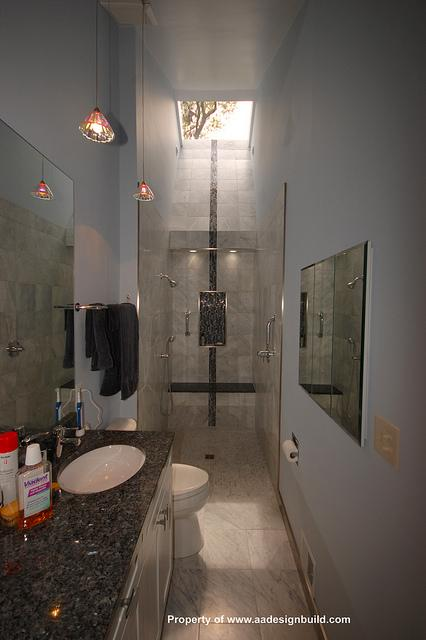What is the item with the white cap used to clean? mouth 